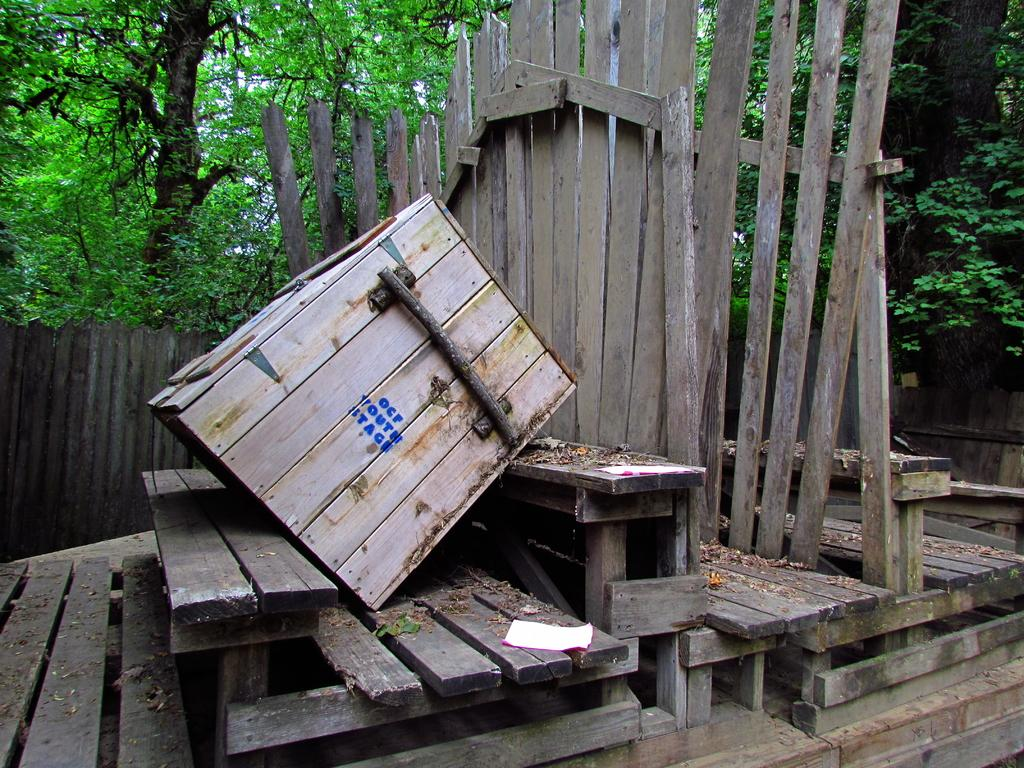What type of objects can be seen in the image? There are papers and wooden objects in the image. Can you describe the wooden objects in the image? There is a wooden fence in the image. What can be seen in the background of the image? There are trees in the background of the image. What type of sound can be heard coming from the wooden objects in the image? There is no sound present in the image, as it is a still image. Is there any cheese visible in the image? There is no cheese present in the image. 